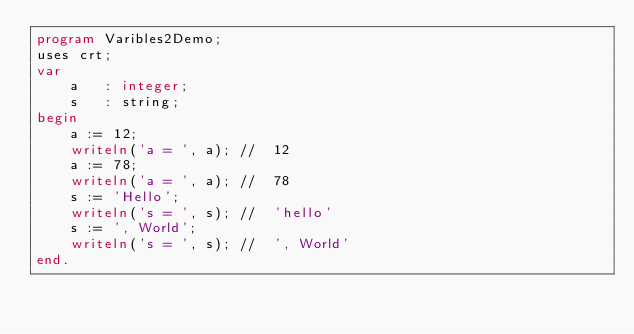Convert code to text. <code><loc_0><loc_0><loc_500><loc_500><_Pascal_>program Varibles2Demo;
uses crt;
var
    a   : integer;
    s   : string;
begin
    a := 12;
    writeln('a = ', a); //  12
    a := 78;
    writeln('a = ', a); //  78
    s := 'Hello';
    writeln('s = ', s); //  'hello'
    s := ', World';
    writeln('s = ', s); //  ', World'
end.</code> 